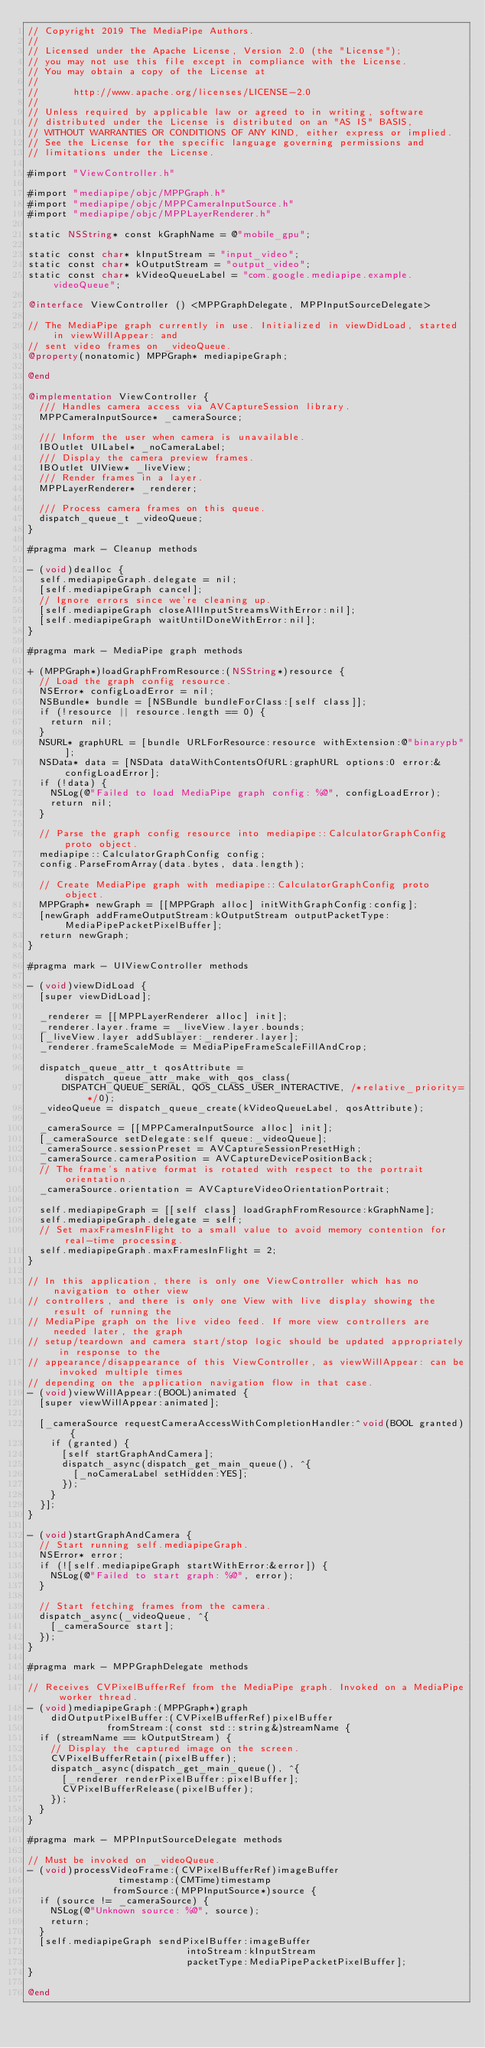<code> <loc_0><loc_0><loc_500><loc_500><_ObjectiveC_>// Copyright 2019 The MediaPipe Authors.
//
// Licensed under the Apache License, Version 2.0 (the "License");
// you may not use this file except in compliance with the License.
// You may obtain a copy of the License at
//
//      http://www.apache.org/licenses/LICENSE-2.0
//
// Unless required by applicable law or agreed to in writing, software
// distributed under the License is distributed on an "AS IS" BASIS,
// WITHOUT WARRANTIES OR CONDITIONS OF ANY KIND, either express or implied.
// See the License for the specific language governing permissions and
// limitations under the License.

#import "ViewController.h"

#import "mediapipe/objc/MPPGraph.h"
#import "mediapipe/objc/MPPCameraInputSource.h"
#import "mediapipe/objc/MPPLayerRenderer.h"

static NSString* const kGraphName = @"mobile_gpu";

static const char* kInputStream = "input_video";
static const char* kOutputStream = "output_video";
static const char* kVideoQueueLabel = "com.google.mediapipe.example.videoQueue";

@interface ViewController () <MPPGraphDelegate, MPPInputSourceDelegate>

// The MediaPipe graph currently in use. Initialized in viewDidLoad, started in viewWillAppear: and
// sent video frames on _videoQueue.
@property(nonatomic) MPPGraph* mediapipeGraph;

@end

@implementation ViewController {
  /// Handles camera access via AVCaptureSession library.
  MPPCameraInputSource* _cameraSource;

  /// Inform the user when camera is unavailable.
  IBOutlet UILabel* _noCameraLabel;
  /// Display the camera preview frames.
  IBOutlet UIView* _liveView;
  /// Render frames in a layer.
  MPPLayerRenderer* _renderer;

  /// Process camera frames on this queue.
  dispatch_queue_t _videoQueue;
}

#pragma mark - Cleanup methods

- (void)dealloc {
  self.mediapipeGraph.delegate = nil;
  [self.mediapipeGraph cancel];
  // Ignore errors since we're cleaning up.
  [self.mediapipeGraph closeAllInputStreamsWithError:nil];
  [self.mediapipeGraph waitUntilDoneWithError:nil];
}

#pragma mark - MediaPipe graph methods

+ (MPPGraph*)loadGraphFromResource:(NSString*)resource {
  // Load the graph config resource.
  NSError* configLoadError = nil;
  NSBundle* bundle = [NSBundle bundleForClass:[self class]];
  if (!resource || resource.length == 0) {
    return nil;
  }
  NSURL* graphURL = [bundle URLForResource:resource withExtension:@"binarypb"];
  NSData* data = [NSData dataWithContentsOfURL:graphURL options:0 error:&configLoadError];
  if (!data) {
    NSLog(@"Failed to load MediaPipe graph config: %@", configLoadError);
    return nil;
  }

  // Parse the graph config resource into mediapipe::CalculatorGraphConfig proto object.
  mediapipe::CalculatorGraphConfig config;
  config.ParseFromArray(data.bytes, data.length);

  // Create MediaPipe graph with mediapipe::CalculatorGraphConfig proto object.
  MPPGraph* newGraph = [[MPPGraph alloc] initWithGraphConfig:config];
  [newGraph addFrameOutputStream:kOutputStream outputPacketType:MediaPipePacketPixelBuffer];
  return newGraph;
}

#pragma mark - UIViewController methods

- (void)viewDidLoad {
  [super viewDidLoad];

  _renderer = [[MPPLayerRenderer alloc] init];
  _renderer.layer.frame = _liveView.layer.bounds;
  [_liveView.layer addSublayer:_renderer.layer];
  _renderer.frameScaleMode = MediaPipeFrameScaleFillAndCrop;

  dispatch_queue_attr_t qosAttribute = dispatch_queue_attr_make_with_qos_class(
      DISPATCH_QUEUE_SERIAL, QOS_CLASS_USER_INTERACTIVE, /*relative_priority=*/0);
  _videoQueue = dispatch_queue_create(kVideoQueueLabel, qosAttribute);

  _cameraSource = [[MPPCameraInputSource alloc] init];
  [_cameraSource setDelegate:self queue:_videoQueue];
  _cameraSource.sessionPreset = AVCaptureSessionPresetHigh;
  _cameraSource.cameraPosition = AVCaptureDevicePositionBack;
  // The frame's native format is rotated with respect to the portrait orientation.
  _cameraSource.orientation = AVCaptureVideoOrientationPortrait;

  self.mediapipeGraph = [[self class] loadGraphFromResource:kGraphName];
  self.mediapipeGraph.delegate = self;
  // Set maxFramesInFlight to a small value to avoid memory contention for real-time processing.
  self.mediapipeGraph.maxFramesInFlight = 2;
}

// In this application, there is only one ViewController which has no navigation to other view
// controllers, and there is only one View with live display showing the result of running the
// MediaPipe graph on the live video feed. If more view controllers are needed later, the graph
// setup/teardown and camera start/stop logic should be updated appropriately in response to the
// appearance/disappearance of this ViewController, as viewWillAppear: can be invoked multiple times
// depending on the application navigation flow in that case.
- (void)viewWillAppear:(BOOL)animated {
  [super viewWillAppear:animated];

  [_cameraSource requestCameraAccessWithCompletionHandler:^void(BOOL granted) {
    if (granted) {
      [self startGraphAndCamera];
      dispatch_async(dispatch_get_main_queue(), ^{
        [_noCameraLabel setHidden:YES];
      });
    }
  }];
}

- (void)startGraphAndCamera {
  // Start running self.mediapipeGraph.
  NSError* error;
  if (![self.mediapipeGraph startWithError:&error]) {
    NSLog(@"Failed to start graph: %@", error);
  }

  // Start fetching frames from the camera.
  dispatch_async(_videoQueue, ^{
    [_cameraSource start];
  });
}

#pragma mark - MPPGraphDelegate methods

// Receives CVPixelBufferRef from the MediaPipe graph. Invoked on a MediaPipe worker thread.
- (void)mediapipeGraph:(MPPGraph*)graph
    didOutputPixelBuffer:(CVPixelBufferRef)pixelBuffer
              fromStream:(const std::string&)streamName {
  if (streamName == kOutputStream) {
    // Display the captured image on the screen.
    CVPixelBufferRetain(pixelBuffer);
    dispatch_async(dispatch_get_main_queue(), ^{
      [_renderer renderPixelBuffer:pixelBuffer];
      CVPixelBufferRelease(pixelBuffer);
    });
  }
}

#pragma mark - MPPInputSourceDelegate methods

// Must be invoked on _videoQueue.
- (void)processVideoFrame:(CVPixelBufferRef)imageBuffer
                timestamp:(CMTime)timestamp
               fromSource:(MPPInputSource*)source {
  if (source != _cameraSource) {
    NSLog(@"Unknown source: %@", source);
    return;
  }
  [self.mediapipeGraph sendPixelBuffer:imageBuffer
                            intoStream:kInputStream
                            packetType:MediaPipePacketPixelBuffer];
}

@end
</code> 